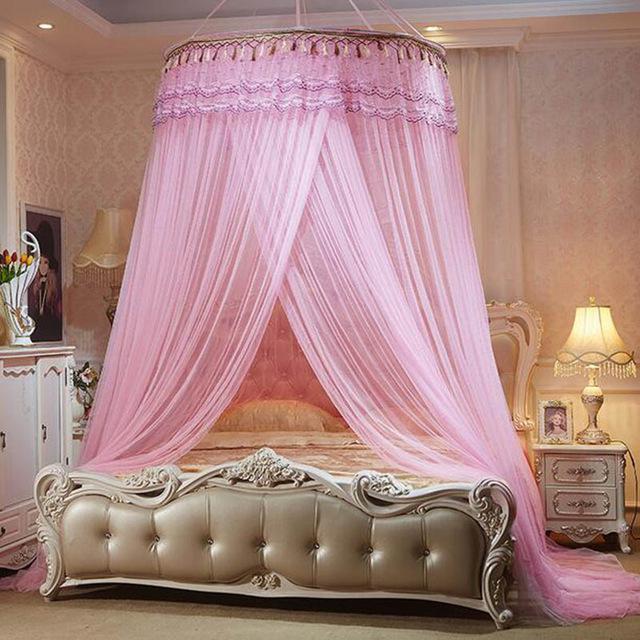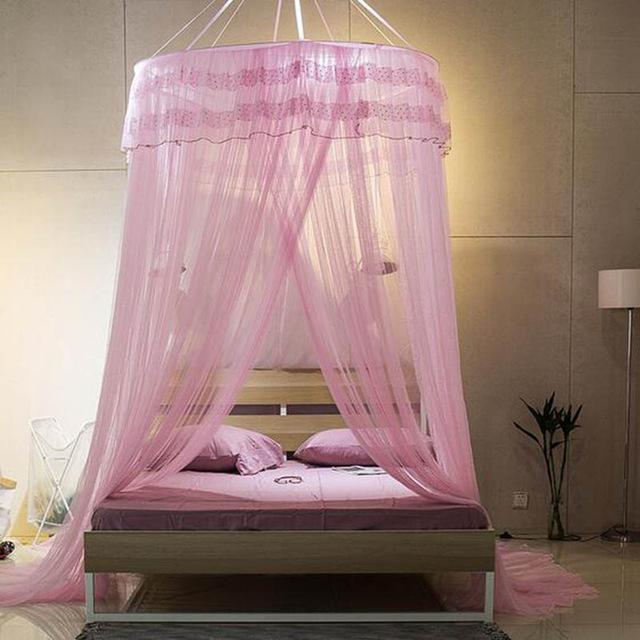The first image is the image on the left, the second image is the image on the right. For the images shown, is this caption "The image on the left contains a pink circular net over a bed." true? Answer yes or no. Yes. The first image is the image on the left, the second image is the image on the right. Given the left and right images, does the statement "One of the beds has four posts." hold true? Answer yes or no. No. 